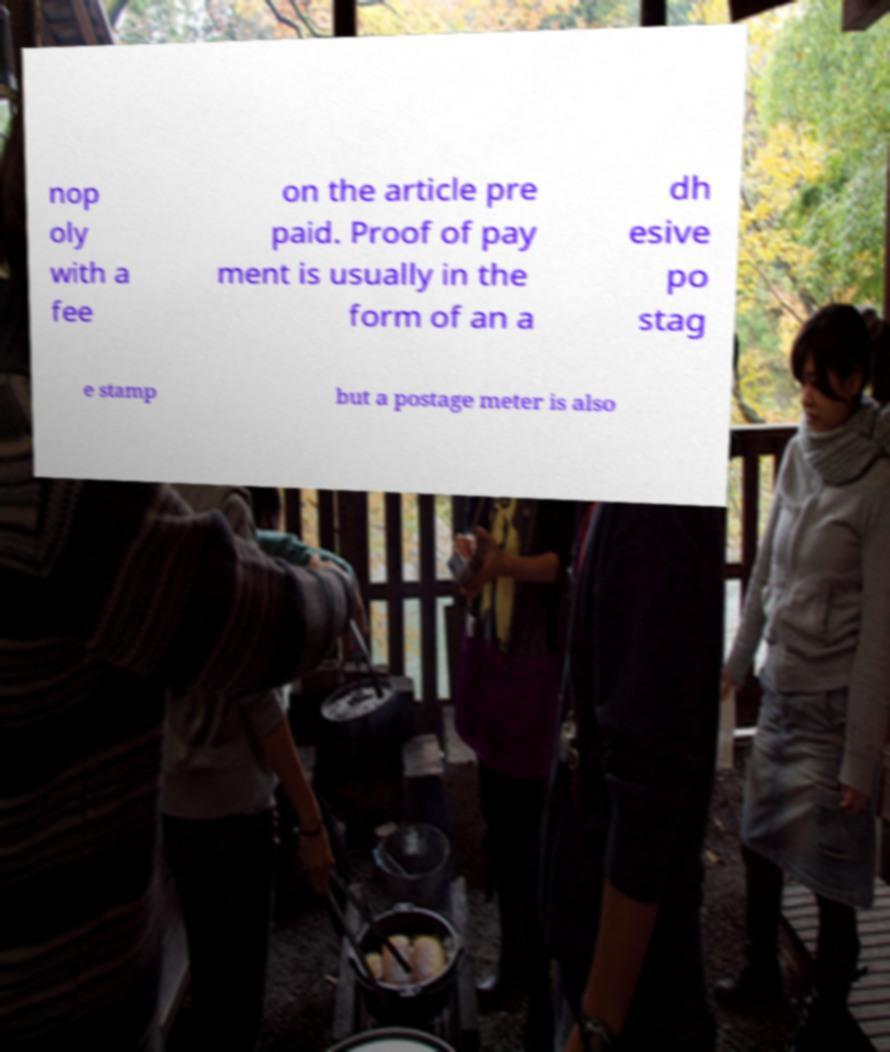I need the written content from this picture converted into text. Can you do that? nop oly with a fee on the article pre paid. Proof of pay ment is usually in the form of an a dh esive po stag e stamp but a postage meter is also 